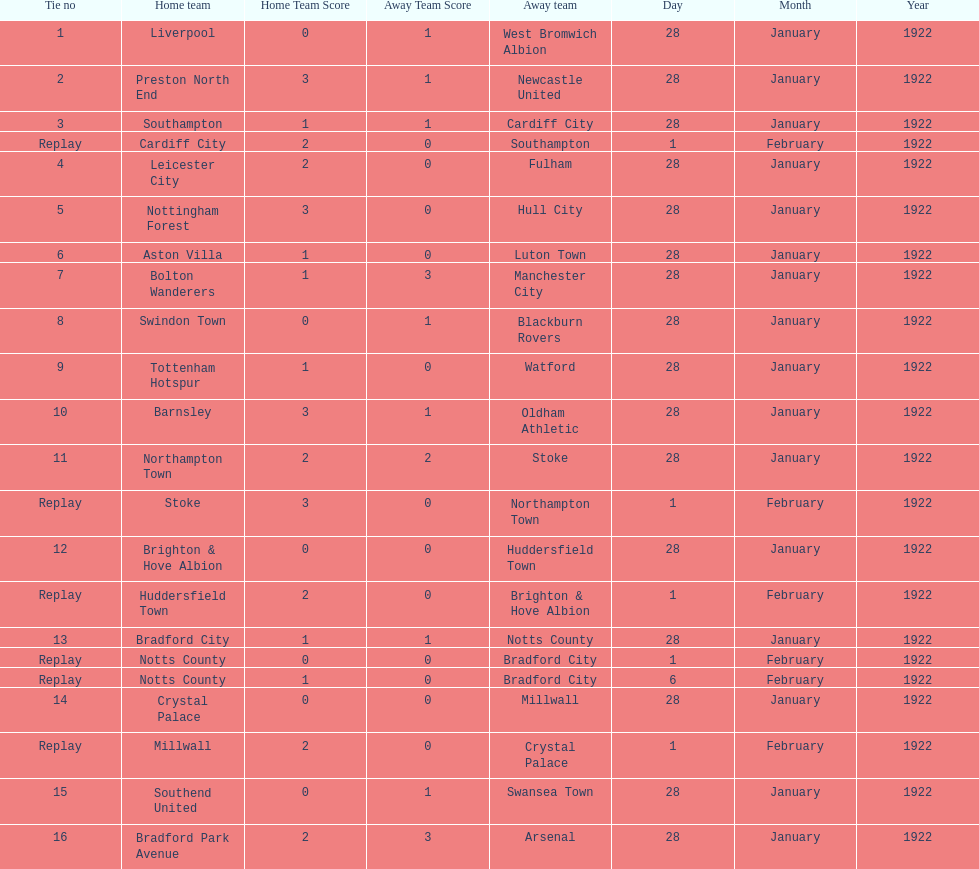Who is the first home team listed as having a score of 3-1? Preston North End. 